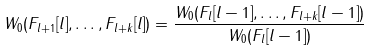Convert formula to latex. <formula><loc_0><loc_0><loc_500><loc_500>W _ { 0 } ( F _ { l + 1 } [ l ] , \dots , F _ { l + k } [ l ] ) = \frac { W _ { 0 } ( F _ { l } [ l - 1 ] , \dots , F _ { l + k } [ l - 1 ] ) } { W _ { 0 } ( F _ { l } [ l - 1 ] ) }</formula> 